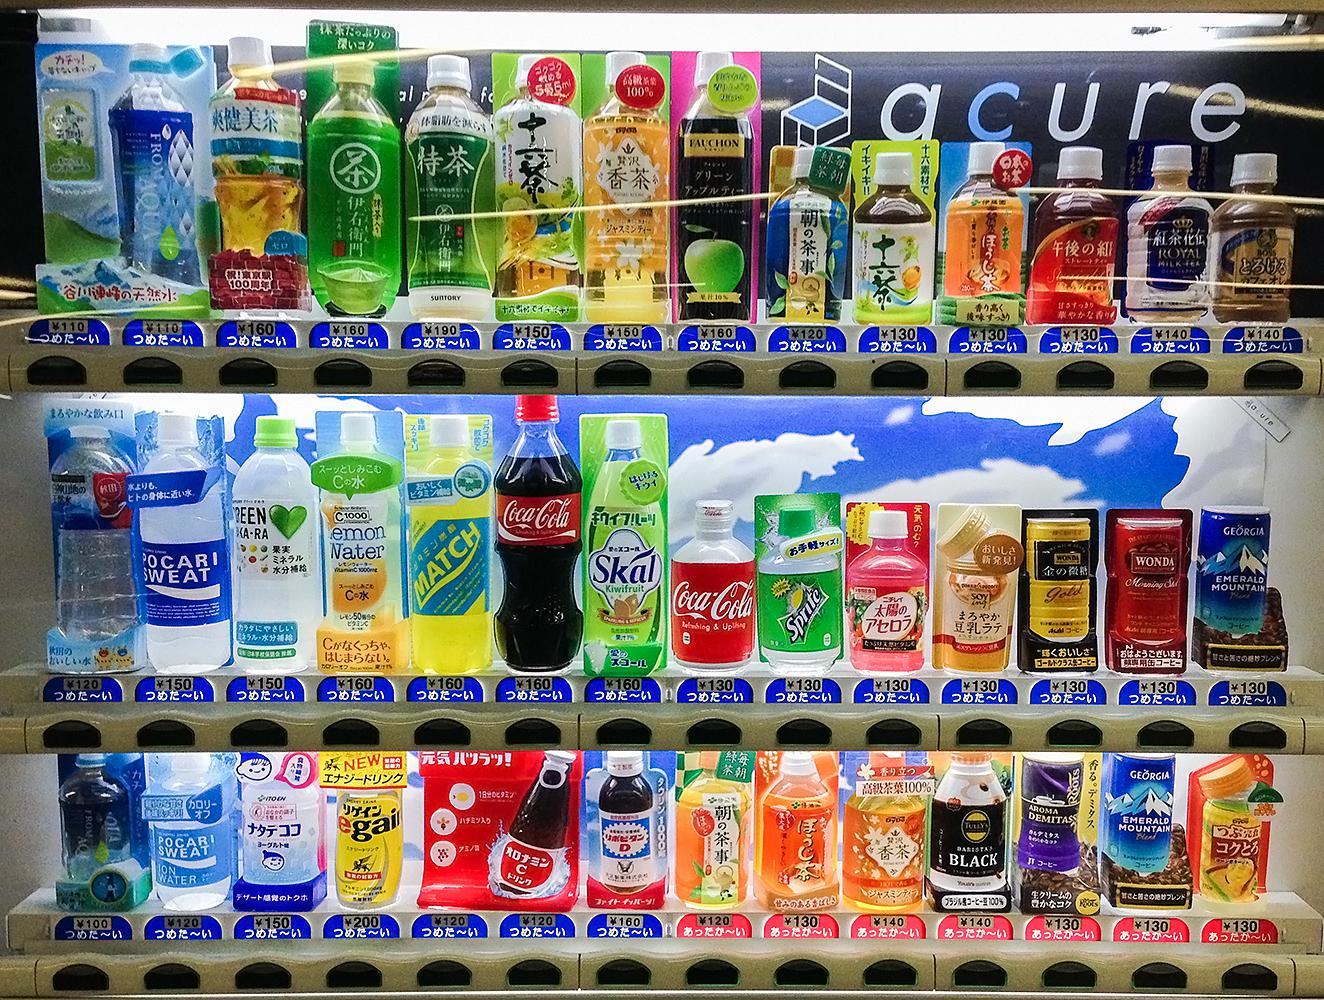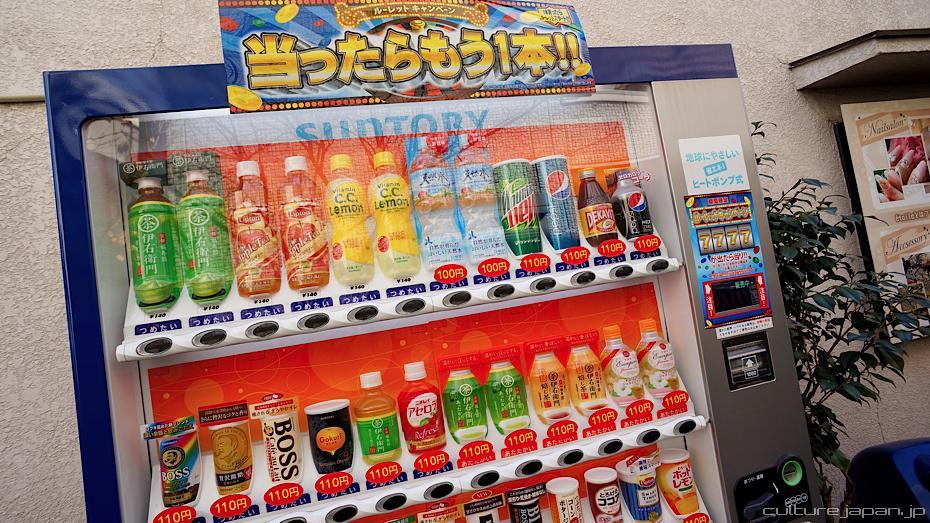The first image is the image on the left, the second image is the image on the right. For the images shown, is this caption "At least one vending machine has a background with bright blue predominant." true? Answer yes or no. Yes. The first image is the image on the left, the second image is the image on the right. Considering the images on both sides, is "The wall against which the vending machine is placed can be seen in one of the images." valid? Answer yes or no. Yes. 